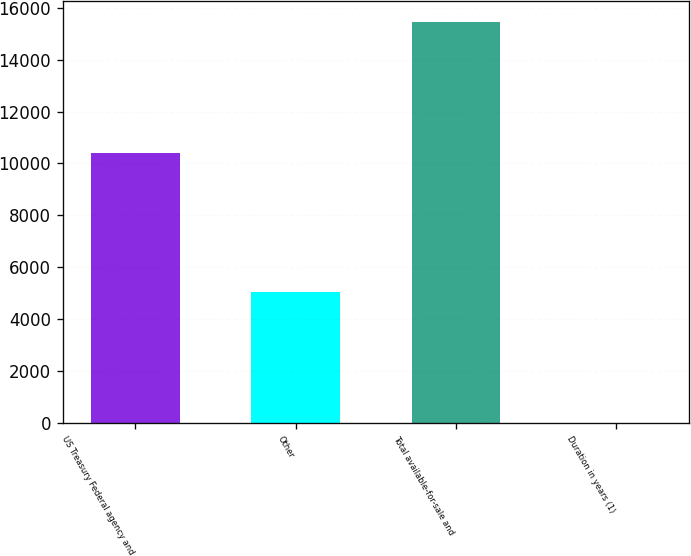<chart> <loc_0><loc_0><loc_500><loc_500><bar_chart><fcel>US Treasury Federal agency and<fcel>Other<fcel>Total available-for-sale and<fcel>Duration in years (1)<nl><fcel>10413<fcel>5056<fcel>15469<fcel>4.9<nl></chart> 